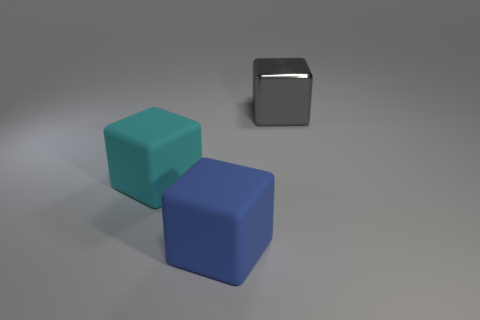What color is the metal object that is the same shape as the large blue matte thing?
Keep it short and to the point. Gray. The cyan matte thing is what size?
Your answer should be compact. Large. There is a big metallic cube behind the big rubber cube behind the blue rubber object; what is its color?
Make the answer very short. Gray. How many large cubes are both behind the big blue thing and left of the gray metal object?
Offer a terse response. 1. Are there more tiny brown things than gray metal things?
Provide a short and direct response. No. What is the material of the gray cube?
Give a very brief answer. Metal. How many rubber objects are in front of the big block that is to the left of the blue matte block?
Provide a succinct answer. 1. There is a rubber thing that is the same size as the blue cube; what is its color?
Give a very brief answer. Cyan. Are there any big gray metallic objects that have the same shape as the blue thing?
Offer a very short reply. Yes. Are there fewer large gray metallic objects than objects?
Your answer should be compact. Yes. 